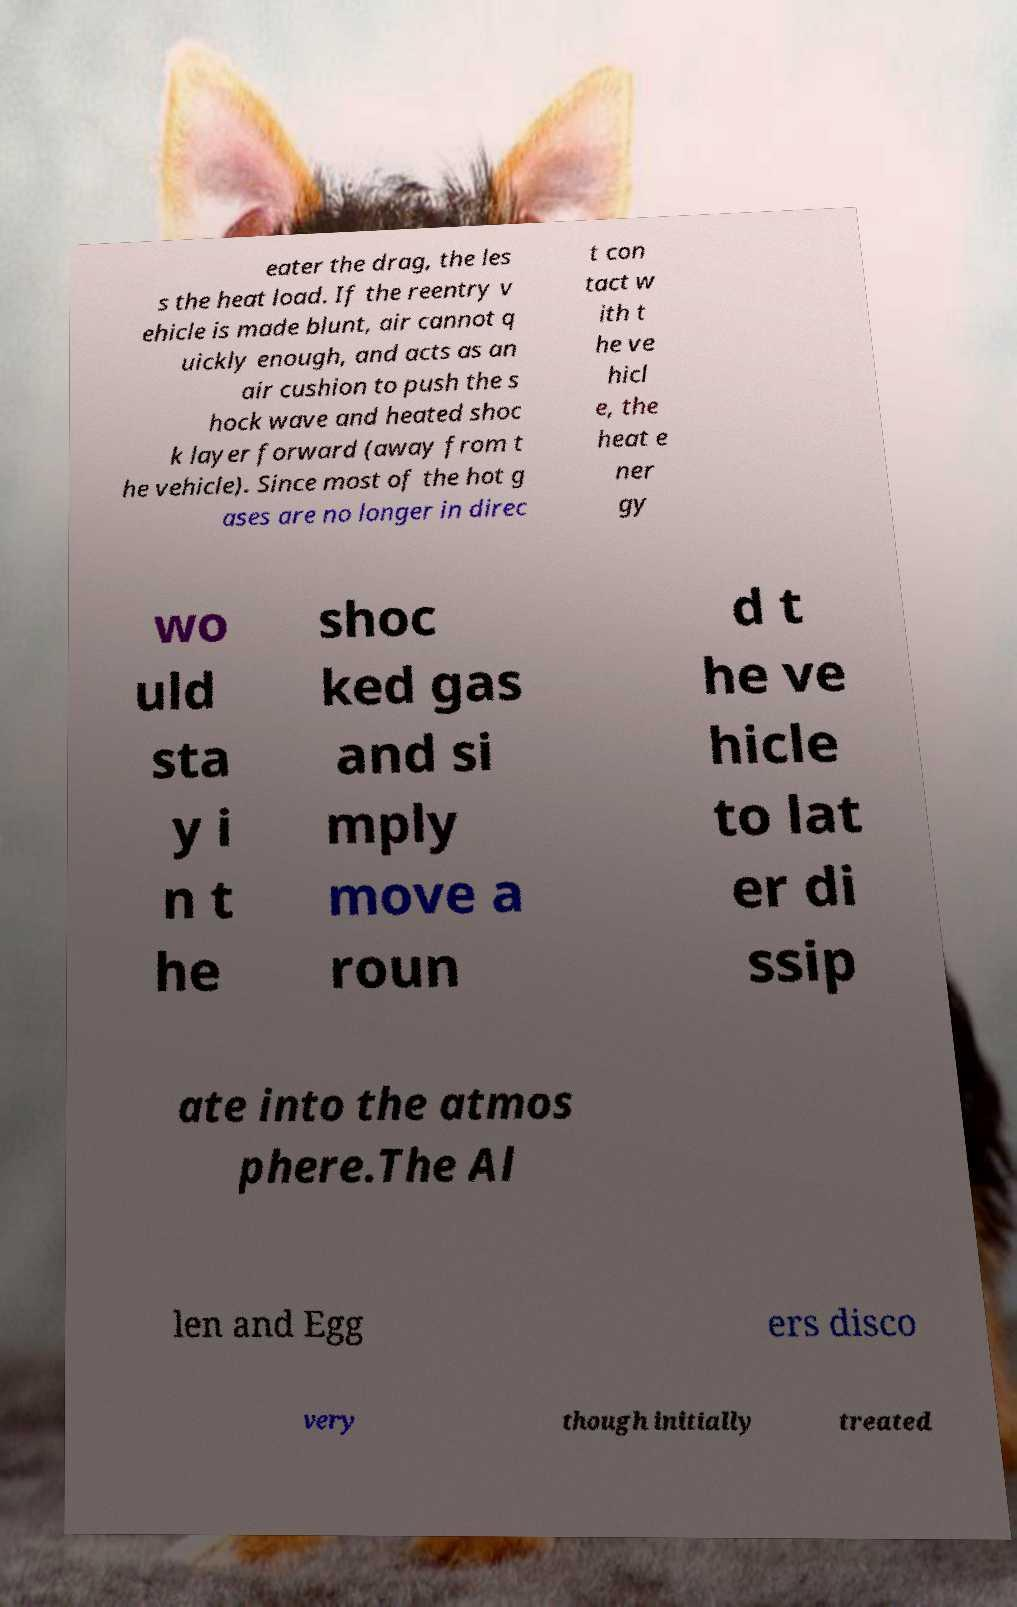For documentation purposes, I need the text within this image transcribed. Could you provide that? eater the drag, the les s the heat load. If the reentry v ehicle is made blunt, air cannot q uickly enough, and acts as an air cushion to push the s hock wave and heated shoc k layer forward (away from t he vehicle). Since most of the hot g ases are no longer in direc t con tact w ith t he ve hicl e, the heat e ner gy wo uld sta y i n t he shoc ked gas and si mply move a roun d t he ve hicle to lat er di ssip ate into the atmos phere.The Al len and Egg ers disco very though initially treated 